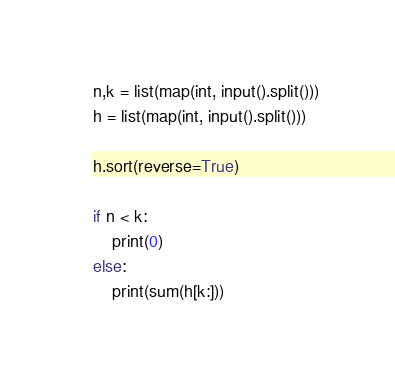Convert code to text. <code><loc_0><loc_0><loc_500><loc_500><_Python_>n,k = list(map(int, input().split()))
h = list(map(int, input().split()))

h.sort(reverse=True)

if n < k:
    print(0)
else:
    print(sum(h[k:]))</code> 